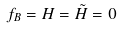<formula> <loc_0><loc_0><loc_500><loc_500>f _ { B } = H = \tilde { H } = 0</formula> 